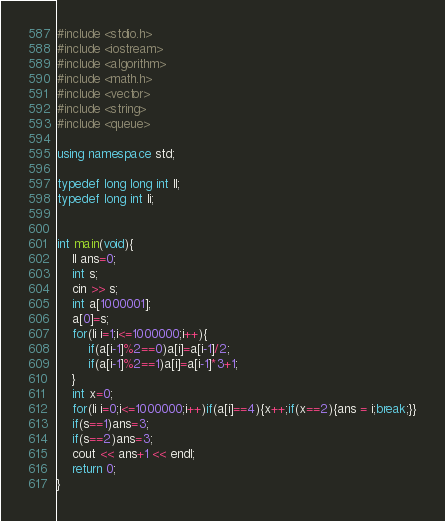<code> <loc_0><loc_0><loc_500><loc_500><_C++_>#include <stdio.h>
#include <iostream>
#include <algorithm>
#include <math.h>
#include <vector>
#include <string>
#include <queue>

using namespace std;

typedef long long int ll;
typedef long int li;


int main(void){
    ll ans=0;
    int s;
    cin >> s;
    int a[1000001];
    a[0]=s;
    for(li i=1;i<=1000000;i++){
        if(a[i-1]%2==0)a[i]=a[i-1]/2;
        if(a[i-1]%2==1)a[i]=a[i-1]*3+1;
    }
    int x=0;
    for(li i=0;i<=1000000;i++)if(a[i]==4){x++;if(x==2){ans = i;break;}}
    if(s==1)ans=3;
    if(s==2)ans=3;
    cout << ans+1 << endl;
    return 0;
}
</code> 